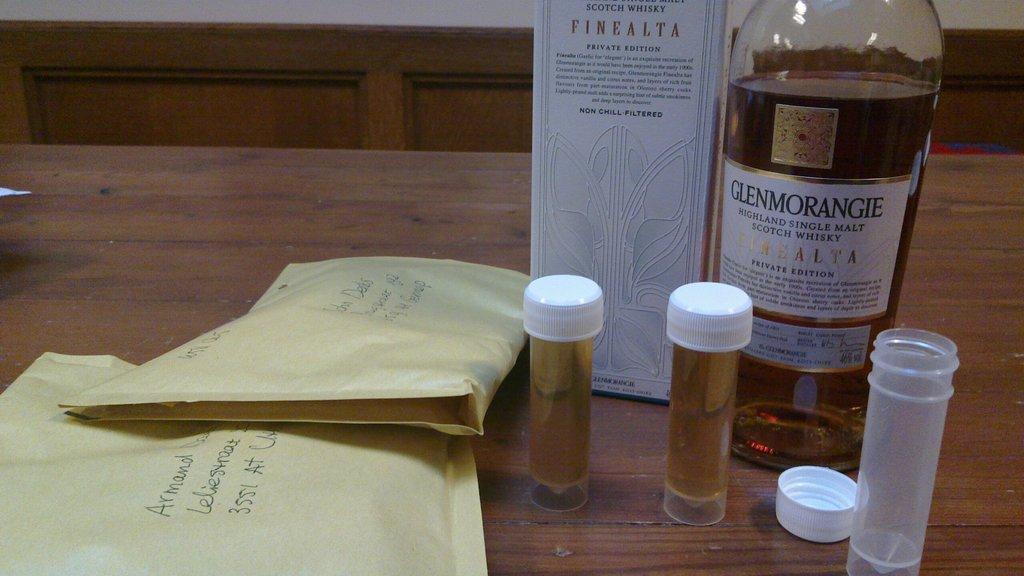What brand of alcohol is this?
Provide a succinct answer. Glenmorangie. 